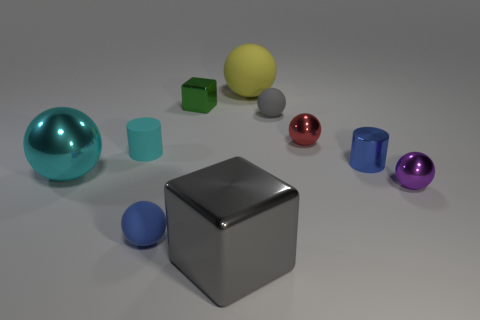There is a yellow object that is the same shape as the purple shiny thing; what is its size?
Your answer should be compact. Large. Is the number of blue matte balls on the right side of the small cyan matte object the same as the number of tiny cyan cylinders that are on the left side of the purple metallic ball?
Provide a short and direct response. Yes. Does the blue metal object that is on the left side of the small purple metallic thing have the same size as the gray thing on the left side of the large yellow rubber sphere?
Provide a succinct answer. No. What is the tiny object that is right of the tiny red thing and behind the big cyan object made of?
Give a very brief answer. Metal. Is the number of big cyan balls less than the number of big blue rubber cylinders?
Ensure brevity in your answer.  No. How big is the metallic sphere on the left side of the gray thing that is left of the large matte sphere?
Provide a succinct answer. Large. What shape is the big metallic object left of the rubber ball that is in front of the tiny metallic object that is in front of the cyan sphere?
Keep it short and to the point. Sphere. There is a large cube that is made of the same material as the blue cylinder; what color is it?
Ensure brevity in your answer.  Gray. There is a big sphere that is behind the small red object to the right of the big ball that is on the right side of the cyan matte cylinder; what color is it?
Your answer should be compact. Yellow. What number of cubes are red objects or big cyan objects?
Your answer should be very brief. 0. 